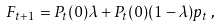Convert formula to latex. <formula><loc_0><loc_0><loc_500><loc_500>F _ { t + 1 } = P _ { t } ( 0 ) \lambda + P _ { t } ( 0 ) ( 1 - \lambda ) p _ { t } \, ,</formula> 